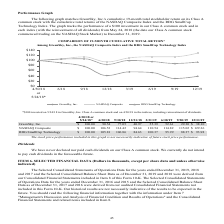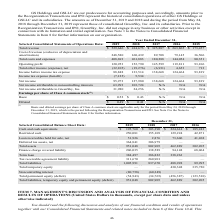From Greensky's financial document, Which years does the table provide information for the company's Selected Consolidated Statements of Operations Data? The document contains multiple relevant values: 2019, 2018, 2017, 2016. From the document: "olidated Statements of Operations Data: 2019 2018 2017 2016 2015 Total revenue $ 529,646 $ 414,673 $ 325,887 $ 263,865 $ 173,457 Cost of revenue (excl..." Also, What was the total revenue in 2015? According to the financial document, 173,457 (in thousands). The relevant text states: "revenue $ 529,646 $ 414,673 $ 325,887 $ 263,865 $ 173,457 Cost of revenue (exclusive of depreciation and amortization) 248,580 160,439 89,708 79,145 36,506 T..." Also, What was the operating profit in 2017? According to the financial document, 145,599 (in thousands). The relevant text states: "8 144,054 80,351 Operating profit 120,953 152,790 145,599 119,811 93,106 Total other income (expense), net (32,105) (19,276) (6,931) 4,653 713 Income before..." Also, How many years did Total costs and expenses exceed $200,000 thousand? Counting the relevant items in the document: 2019, 2018, I find 2 instances. The key data points involved are: 2018, 2019. Also, can you calculate: What was the change in the cost of revenue between 2017 and 2018? Based on the calculation: 160,439-89,708, the result is 70731 (in thousands). This is based on the information: "of depreciation and amortization) 248,580 160,439 89,708 79,145 36,506 Total costs and expenses 408,693 261,883 180,288 144,054 80,351 Operating profit 120, clusive of depreciation and amortization) 2..." The key data points involved are: 160,439, 89,708. Also, can you calculate: What was the percentage change in operating profit between 2015 and 2016? To answer this question, I need to perform calculations using the financial data. The calculation is: (119,811-93,106)/93,106, which equals 28.68 (percentage). This is based on the information: "4 80,351 Operating profit 120,953 152,790 145,599 119,811 93,106 Total other income (expense), net (32,105) (19,276) (6,931) 4,653 713 Income before income t Operating profit 120,953 152,790 145,599 1..." The key data points involved are: 119,811, 93,106. 